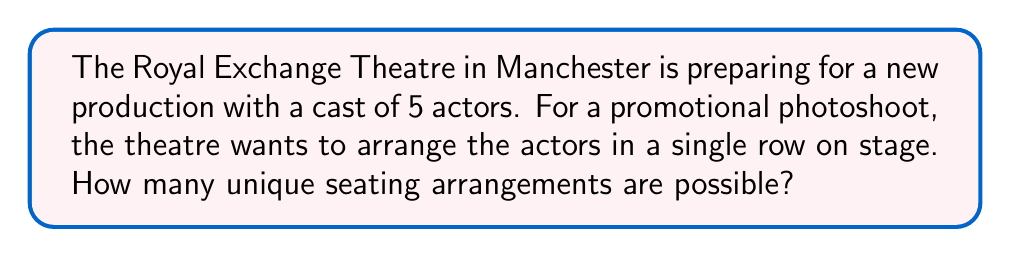Show me your answer to this math problem. To solve this problem, we need to use the concept of permutations from combinatorics. Here's a step-by-step explanation:

1. We have 5 distinct actors, and we want to arrange all of them in a line.

2. This is a perfect scenario for using the permutation formula. The number of permutations of n distinct objects is given by:

   $$P(n) = n!$$

   Where $n!$ represents the factorial of n.

3. In this case, $n = 5$, so we need to calculate $5!$

4. Let's expand this:
   $$5! = 5 \times 4 \times 3 \times 2 \times 1 = 120$$

5. Therefore, there are 120 unique ways to arrange 5 actors in a single row.

This result means that the Royal Exchange Theatre can create 120 different promotional photos with the actors in different orders, providing plenty of variety for their marketing materials.
Answer: $120$ 